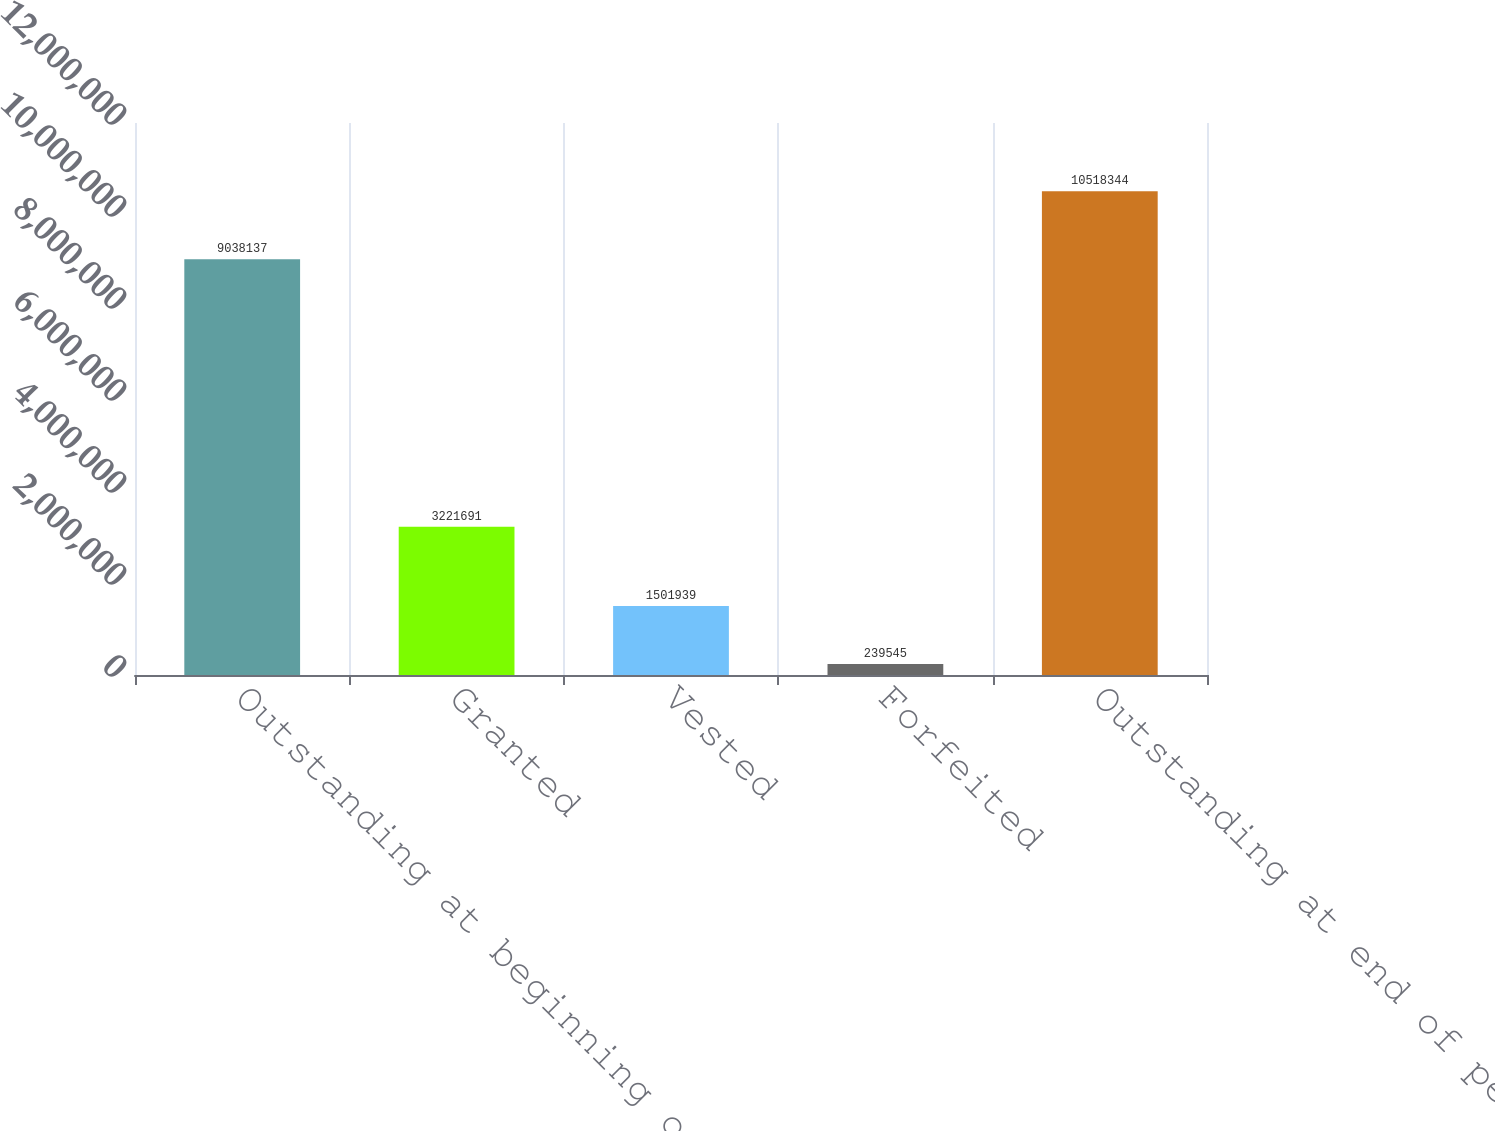<chart> <loc_0><loc_0><loc_500><loc_500><bar_chart><fcel>Outstanding at beginning of<fcel>Granted<fcel>Vested<fcel>Forfeited<fcel>Outstanding at end of period<nl><fcel>9.03814e+06<fcel>3.22169e+06<fcel>1.50194e+06<fcel>239545<fcel>1.05183e+07<nl></chart> 